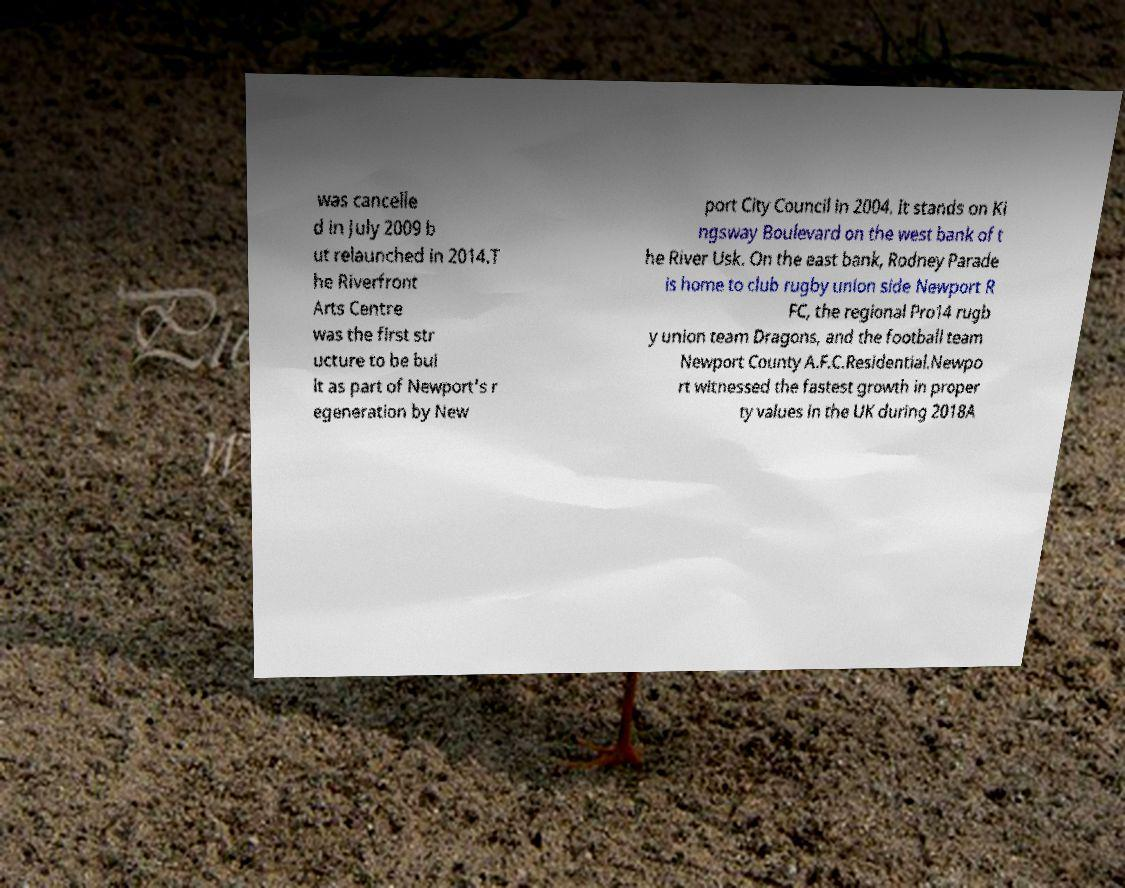Please identify and transcribe the text found in this image. was cancelle d in July 2009 b ut relaunched in 2014.T he Riverfront Arts Centre was the first str ucture to be bui lt as part of Newport's r egeneration by New port City Council in 2004. It stands on Ki ngsway Boulevard on the west bank of t he River Usk. On the east bank, Rodney Parade is home to club rugby union side Newport R FC, the regional Pro14 rugb y union team Dragons, and the football team Newport County A.F.C.Residential.Newpo rt witnessed the fastest growth in proper ty values in the UK during 2018A 